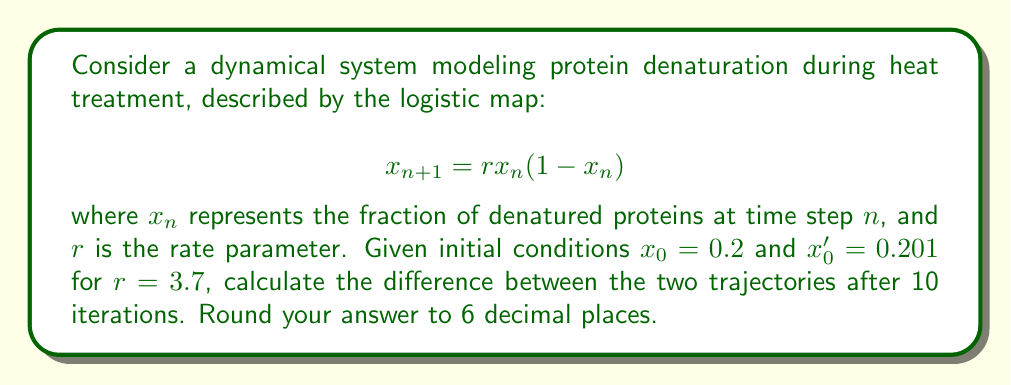Teach me how to tackle this problem. To evaluate the sensitivity to initial conditions, we'll iterate the logistic map for both initial conditions and compare the results:

1) For $x_0 = 0.2$:
   $x_1 = 3.7 \cdot 0.2 \cdot (1-0.2) = 0.592$
   $x_2 = 3.7 \cdot 0.592 \cdot (1-0.592) = 0.892357824$
   $x_3 = 3.7 \cdot 0.892357824 \cdot (1-0.892357824) = 0.355611246$
   ...
   $x_{10} = 0.876048259$

2) For $x_0' = 0.201$:
   $x_1' = 3.7 \cdot 0.201 \cdot (1-0.201) = 0.594207$
   $x_2' = 3.7 \cdot 0.594207 \cdot (1-0.594207) = 0.890775662$
   $x_3' = 3.7 \cdot 0.890775662 \cdot (1-0.890775662) = 0.359614175$
   ...
   $x_{10}' = 0.648253372$

3) Calculate the difference:
   $|x_{10} - x_{10}'| = |0.876048259 - 0.648253372| = 0.227794887$

4) Round to 6 decimal places: 0.227795

This significant difference after only 10 iterations, despite a small initial difference of 0.001, demonstrates the system's sensitivity to initial conditions, a key characteristic of chaotic systems.
Answer: 0.227795 